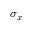Convert formula to latex. <formula><loc_0><loc_0><loc_500><loc_500>\sigma _ { x }</formula> 